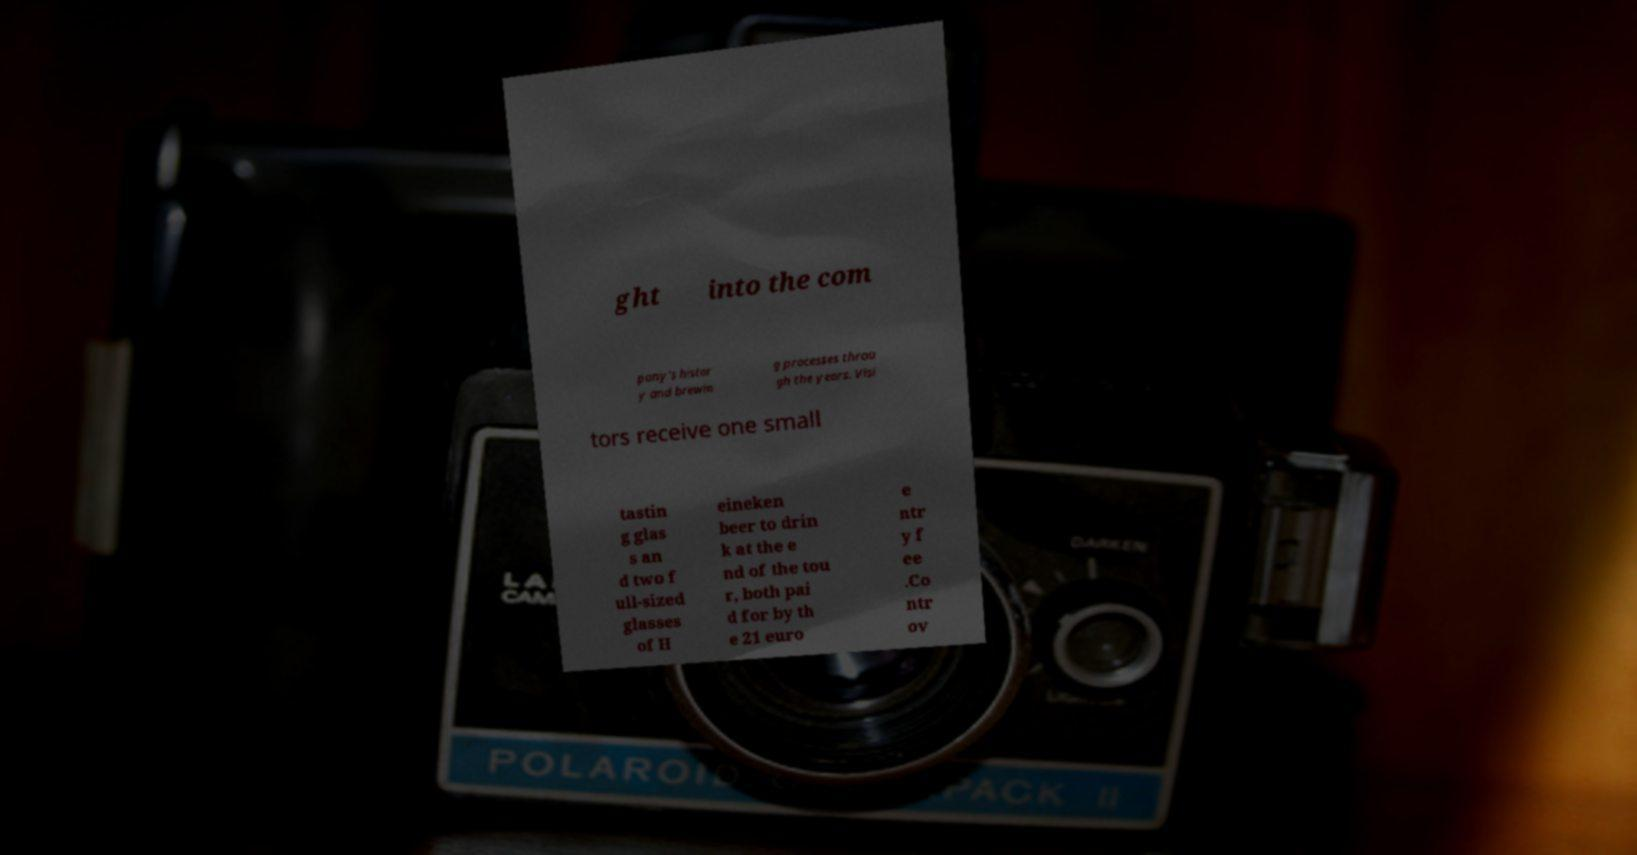Please identify and transcribe the text found in this image. ght into the com pany's histor y and brewin g processes throu gh the years. Visi tors receive one small tastin g glas s an d two f ull-sized glasses of H eineken beer to drin k at the e nd of the tou r, both pai d for by th e 21 euro e ntr y f ee .Co ntr ov 